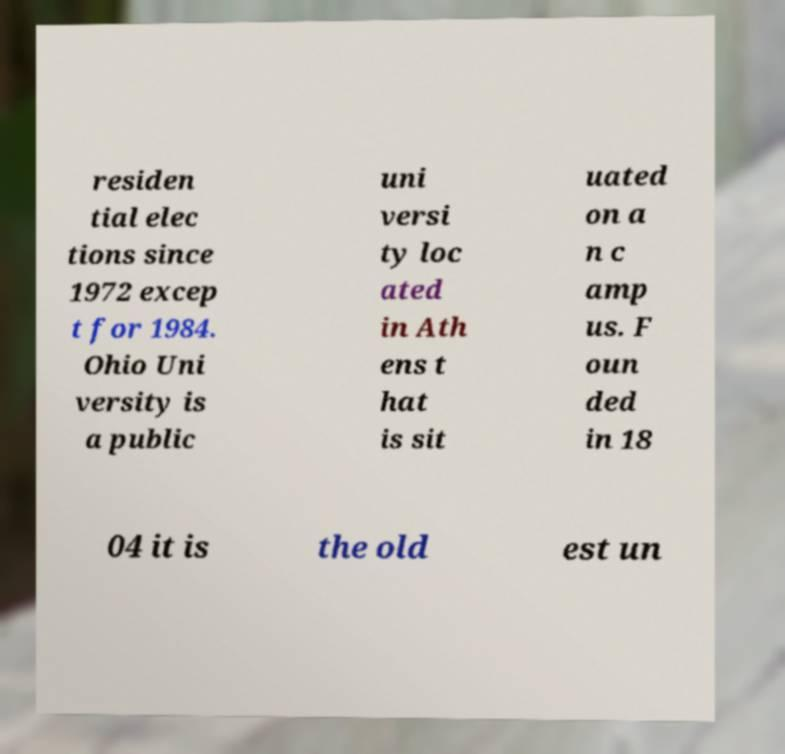Could you extract and type out the text from this image? residen tial elec tions since 1972 excep t for 1984. Ohio Uni versity is a public uni versi ty loc ated in Ath ens t hat is sit uated on a n c amp us. F oun ded in 18 04 it is the old est un 